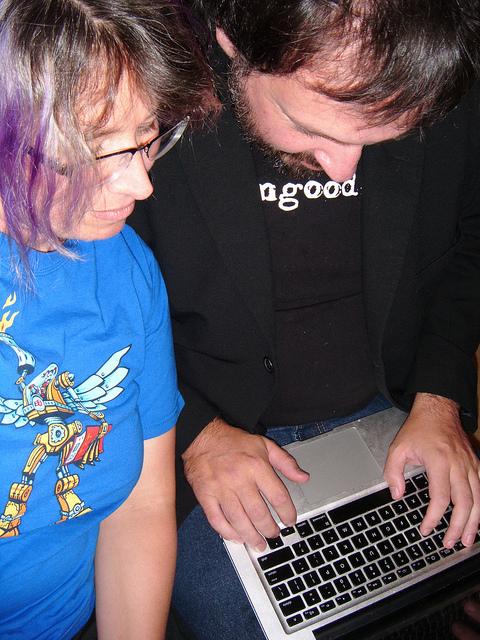What is the man using?
Write a very short answer. Laptop. What kind of print is on her t-shirt?
Answer briefly. Cartoon. Is the woman wearing glasses?
Concise answer only. Yes. 